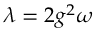Convert formula to latex. <formula><loc_0><loc_0><loc_500><loc_500>\lambda = 2 g ^ { 2 } \omega</formula> 